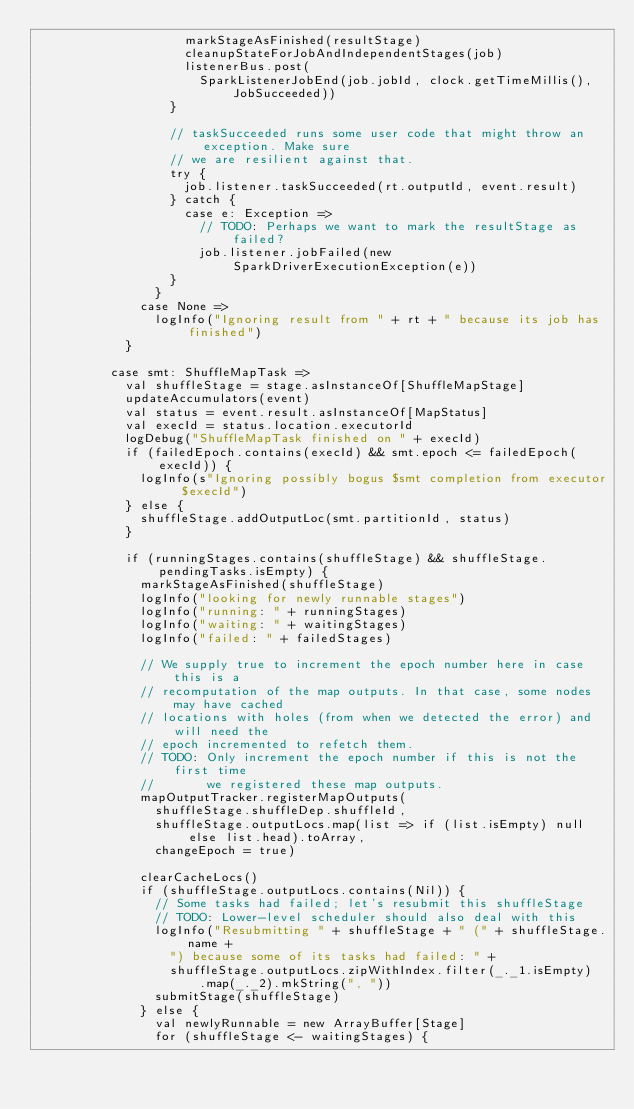<code> <loc_0><loc_0><loc_500><loc_500><_Scala_>                    markStageAsFinished(resultStage)
                    cleanupStateForJobAndIndependentStages(job)
                    listenerBus.post(
                      SparkListenerJobEnd(job.jobId, clock.getTimeMillis(), JobSucceeded))
                  }

                  // taskSucceeded runs some user code that might throw an exception. Make sure
                  // we are resilient against that.
                  try {
                    job.listener.taskSucceeded(rt.outputId, event.result)
                  } catch {
                    case e: Exception =>
                      // TODO: Perhaps we want to mark the resultStage as failed?
                      job.listener.jobFailed(new SparkDriverExecutionException(e))
                  }
                }
              case None =>
                logInfo("Ignoring result from " + rt + " because its job has finished")
            }

          case smt: ShuffleMapTask =>
            val shuffleStage = stage.asInstanceOf[ShuffleMapStage]
            updateAccumulators(event)
            val status = event.result.asInstanceOf[MapStatus]
            val execId = status.location.executorId
            logDebug("ShuffleMapTask finished on " + execId)
            if (failedEpoch.contains(execId) && smt.epoch <= failedEpoch(execId)) {
              logInfo(s"Ignoring possibly bogus $smt completion from executor $execId")
            } else {
              shuffleStage.addOutputLoc(smt.partitionId, status)
            }

            if (runningStages.contains(shuffleStage) && shuffleStage.pendingTasks.isEmpty) {
              markStageAsFinished(shuffleStage)
              logInfo("looking for newly runnable stages")
              logInfo("running: " + runningStages)
              logInfo("waiting: " + waitingStages)
              logInfo("failed: " + failedStages)

              // We supply true to increment the epoch number here in case this is a
              // recomputation of the map outputs. In that case, some nodes may have cached
              // locations with holes (from when we detected the error) and will need the
              // epoch incremented to refetch them.
              // TODO: Only increment the epoch number if this is not the first time
              //       we registered these map outputs.
              mapOutputTracker.registerMapOutputs(
                shuffleStage.shuffleDep.shuffleId,
                shuffleStage.outputLocs.map(list => if (list.isEmpty) null else list.head).toArray,
                changeEpoch = true)

              clearCacheLocs()
              if (shuffleStage.outputLocs.contains(Nil)) {
                // Some tasks had failed; let's resubmit this shuffleStage
                // TODO: Lower-level scheduler should also deal with this
                logInfo("Resubmitting " + shuffleStage + " (" + shuffleStage.name +
                  ") because some of its tasks had failed: " +
                  shuffleStage.outputLocs.zipWithIndex.filter(_._1.isEmpty)
                      .map(_._2).mkString(", "))
                submitStage(shuffleStage)
              } else {
                val newlyRunnable = new ArrayBuffer[Stage]
                for (shuffleStage <- waitingStages) {</code> 